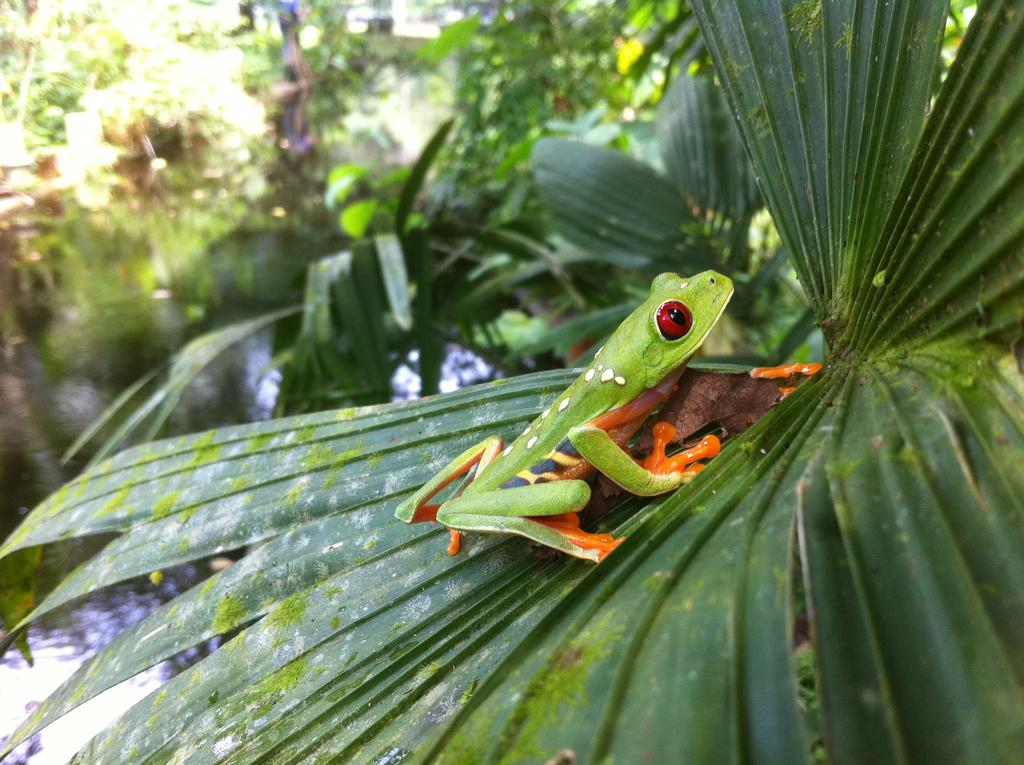What animal is in the picture? There is a green frog in the picture. Where is the frog sitting? The frog is sitting on a big leaf. What can be seen in the background of the picture? There are green leaves and plants in the background of the picture. What type of rice is being prepared in the background of the image? There is no rice present in the image; it features a green frog sitting on a big leaf with green leaves and plants in the background. 